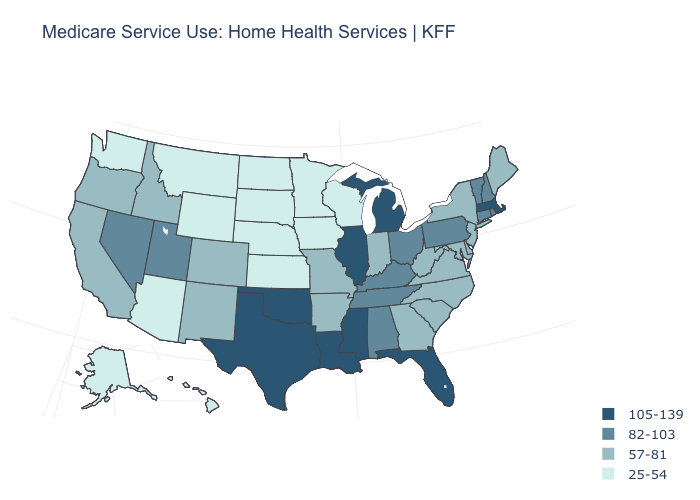What is the highest value in the USA?
Write a very short answer. 105-139. How many symbols are there in the legend?
Write a very short answer. 4. How many symbols are there in the legend?
Give a very brief answer. 4. Does Vermont have the highest value in the Northeast?
Be succinct. No. Name the states that have a value in the range 57-81?
Be succinct. Arkansas, California, Colorado, Delaware, Georgia, Idaho, Indiana, Maine, Maryland, Missouri, New Jersey, New Mexico, New York, North Carolina, Oregon, South Carolina, Virginia, West Virginia. Among the states that border Alabama , which have the highest value?
Quick response, please. Florida, Mississippi. Among the states that border Alabama , which have the lowest value?
Concise answer only. Georgia. Which states have the lowest value in the West?
Quick response, please. Alaska, Arizona, Hawaii, Montana, Washington, Wyoming. Does Arizona have the highest value in the USA?
Short answer required. No. What is the lowest value in the MidWest?
Concise answer only. 25-54. Which states have the lowest value in the South?
Short answer required. Arkansas, Delaware, Georgia, Maryland, North Carolina, South Carolina, Virginia, West Virginia. Name the states that have a value in the range 82-103?
Answer briefly. Alabama, Connecticut, Kentucky, Nevada, New Hampshire, Ohio, Pennsylvania, Rhode Island, Tennessee, Utah, Vermont. Which states have the lowest value in the USA?
Keep it brief. Alaska, Arizona, Hawaii, Iowa, Kansas, Minnesota, Montana, Nebraska, North Dakota, South Dakota, Washington, Wisconsin, Wyoming. What is the lowest value in the South?
Keep it brief. 57-81. Name the states that have a value in the range 57-81?
Concise answer only. Arkansas, California, Colorado, Delaware, Georgia, Idaho, Indiana, Maine, Maryland, Missouri, New Jersey, New Mexico, New York, North Carolina, Oregon, South Carolina, Virginia, West Virginia. 